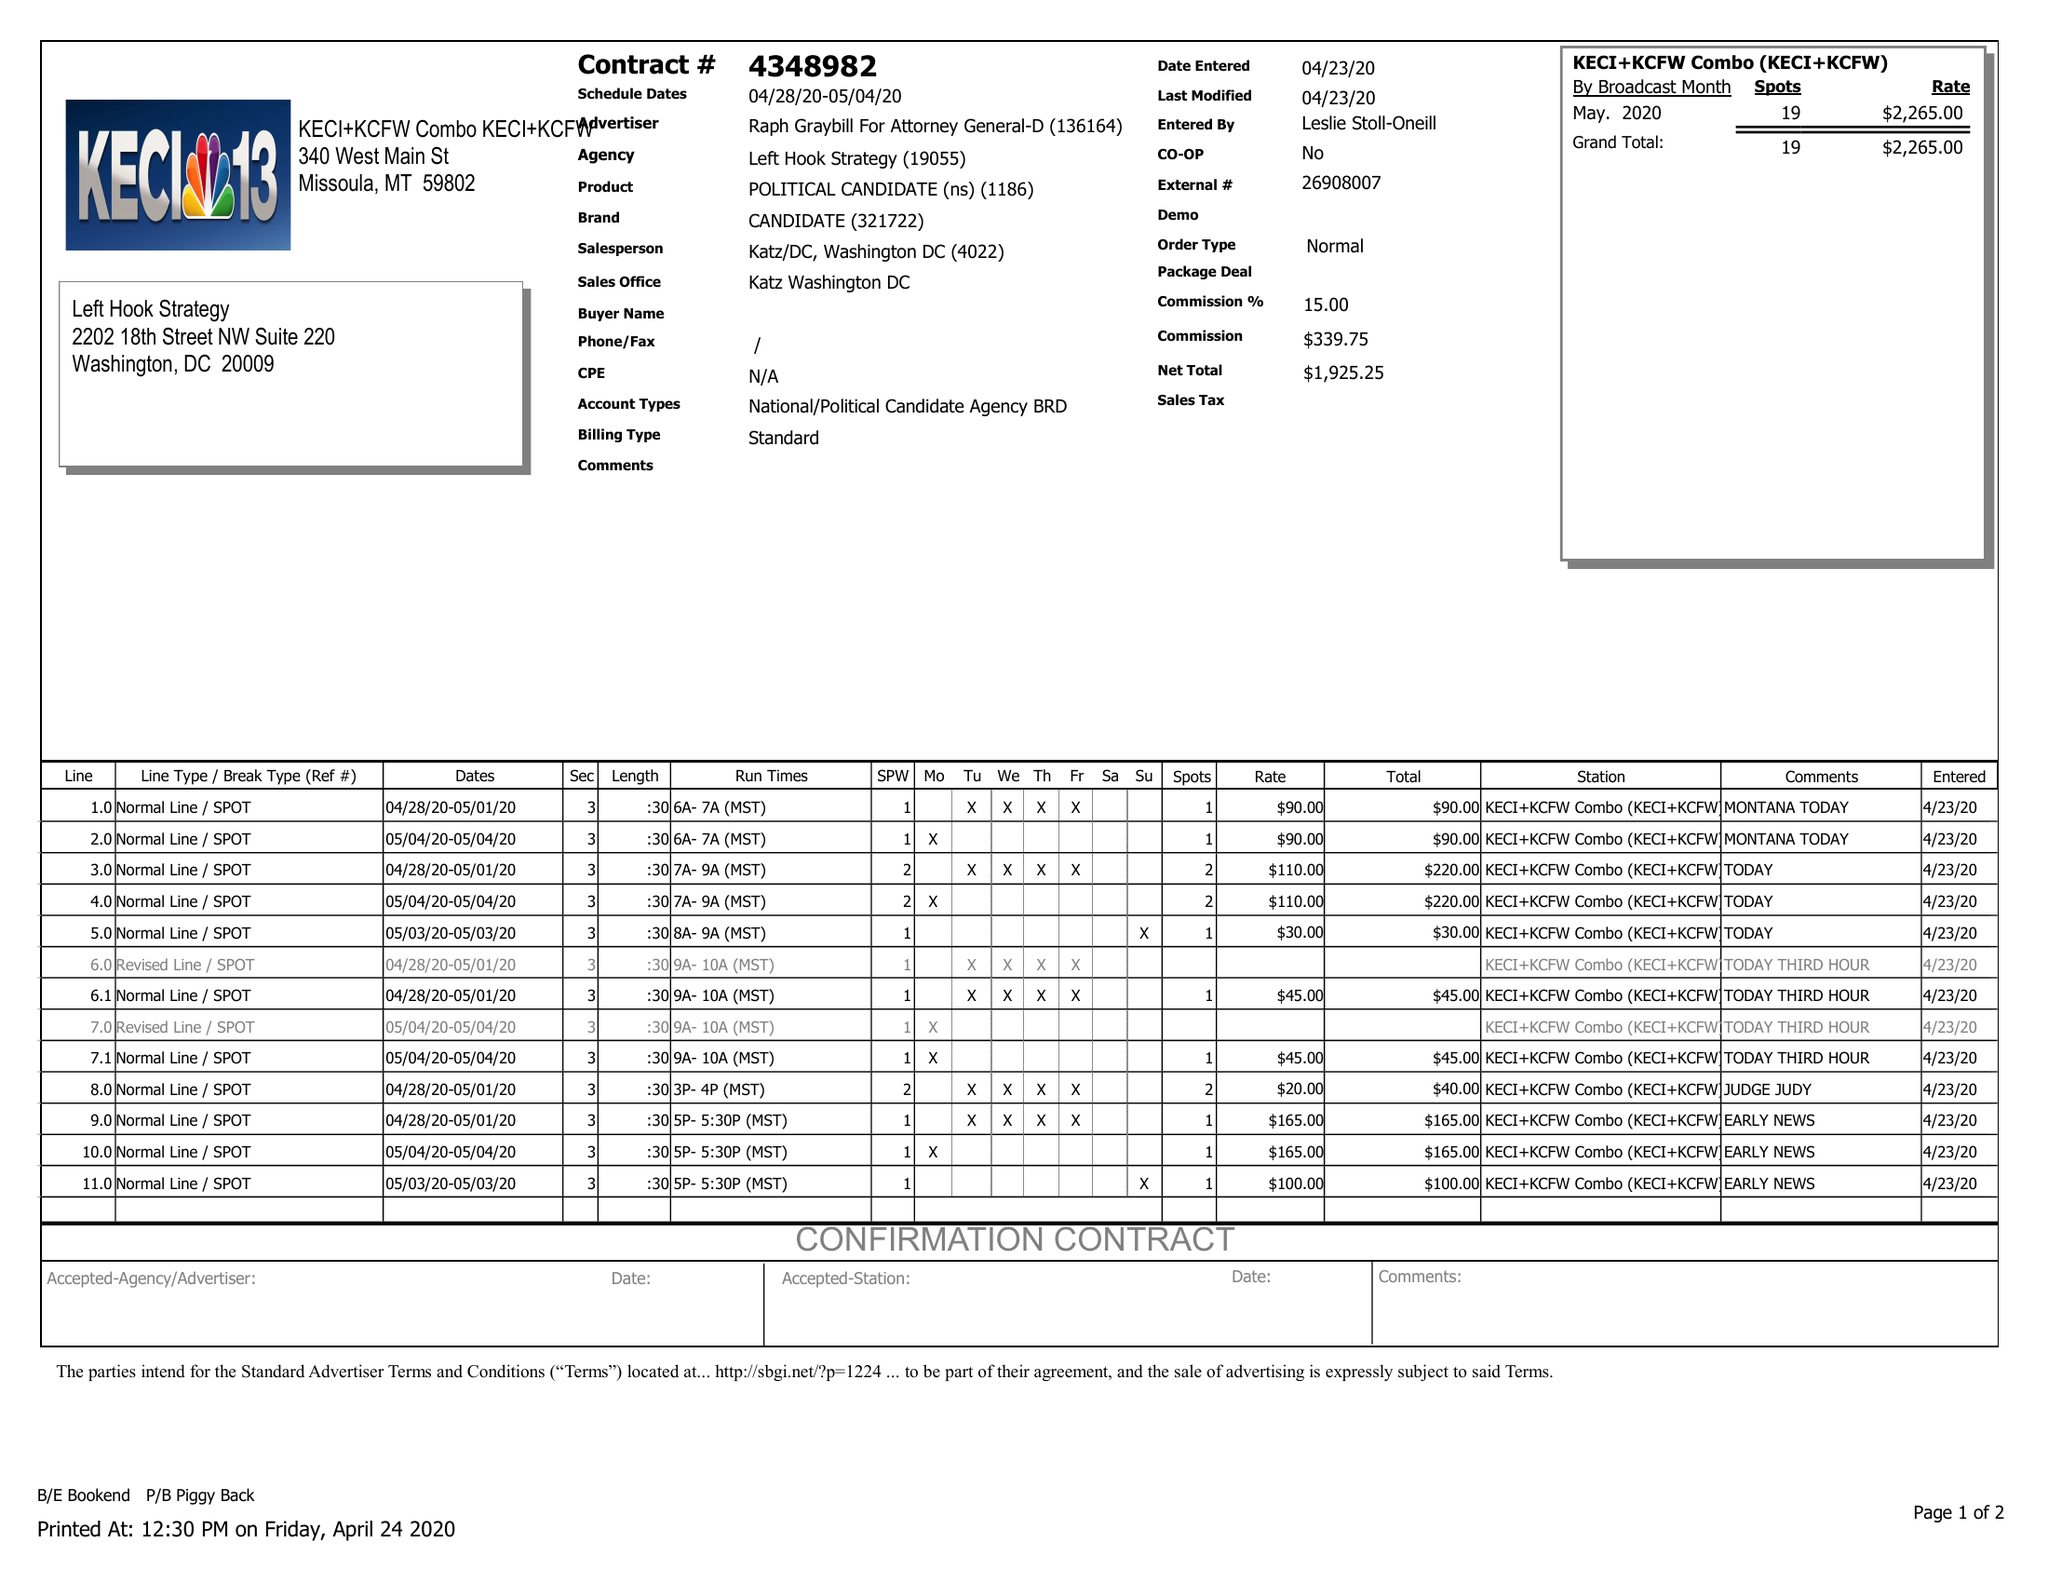What is the value for the contract_num?
Answer the question using a single word or phrase. 4348982 